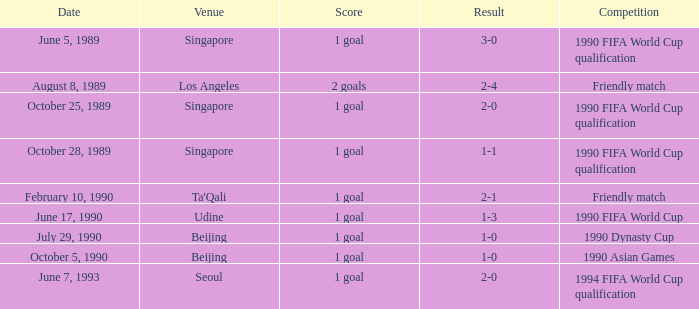What was the outcome of the game that ended 3-0? 1 goal. 